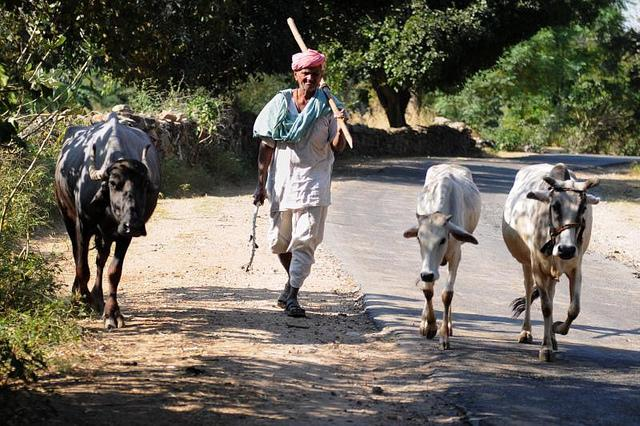How many cows are following around the man in the red turban? three 